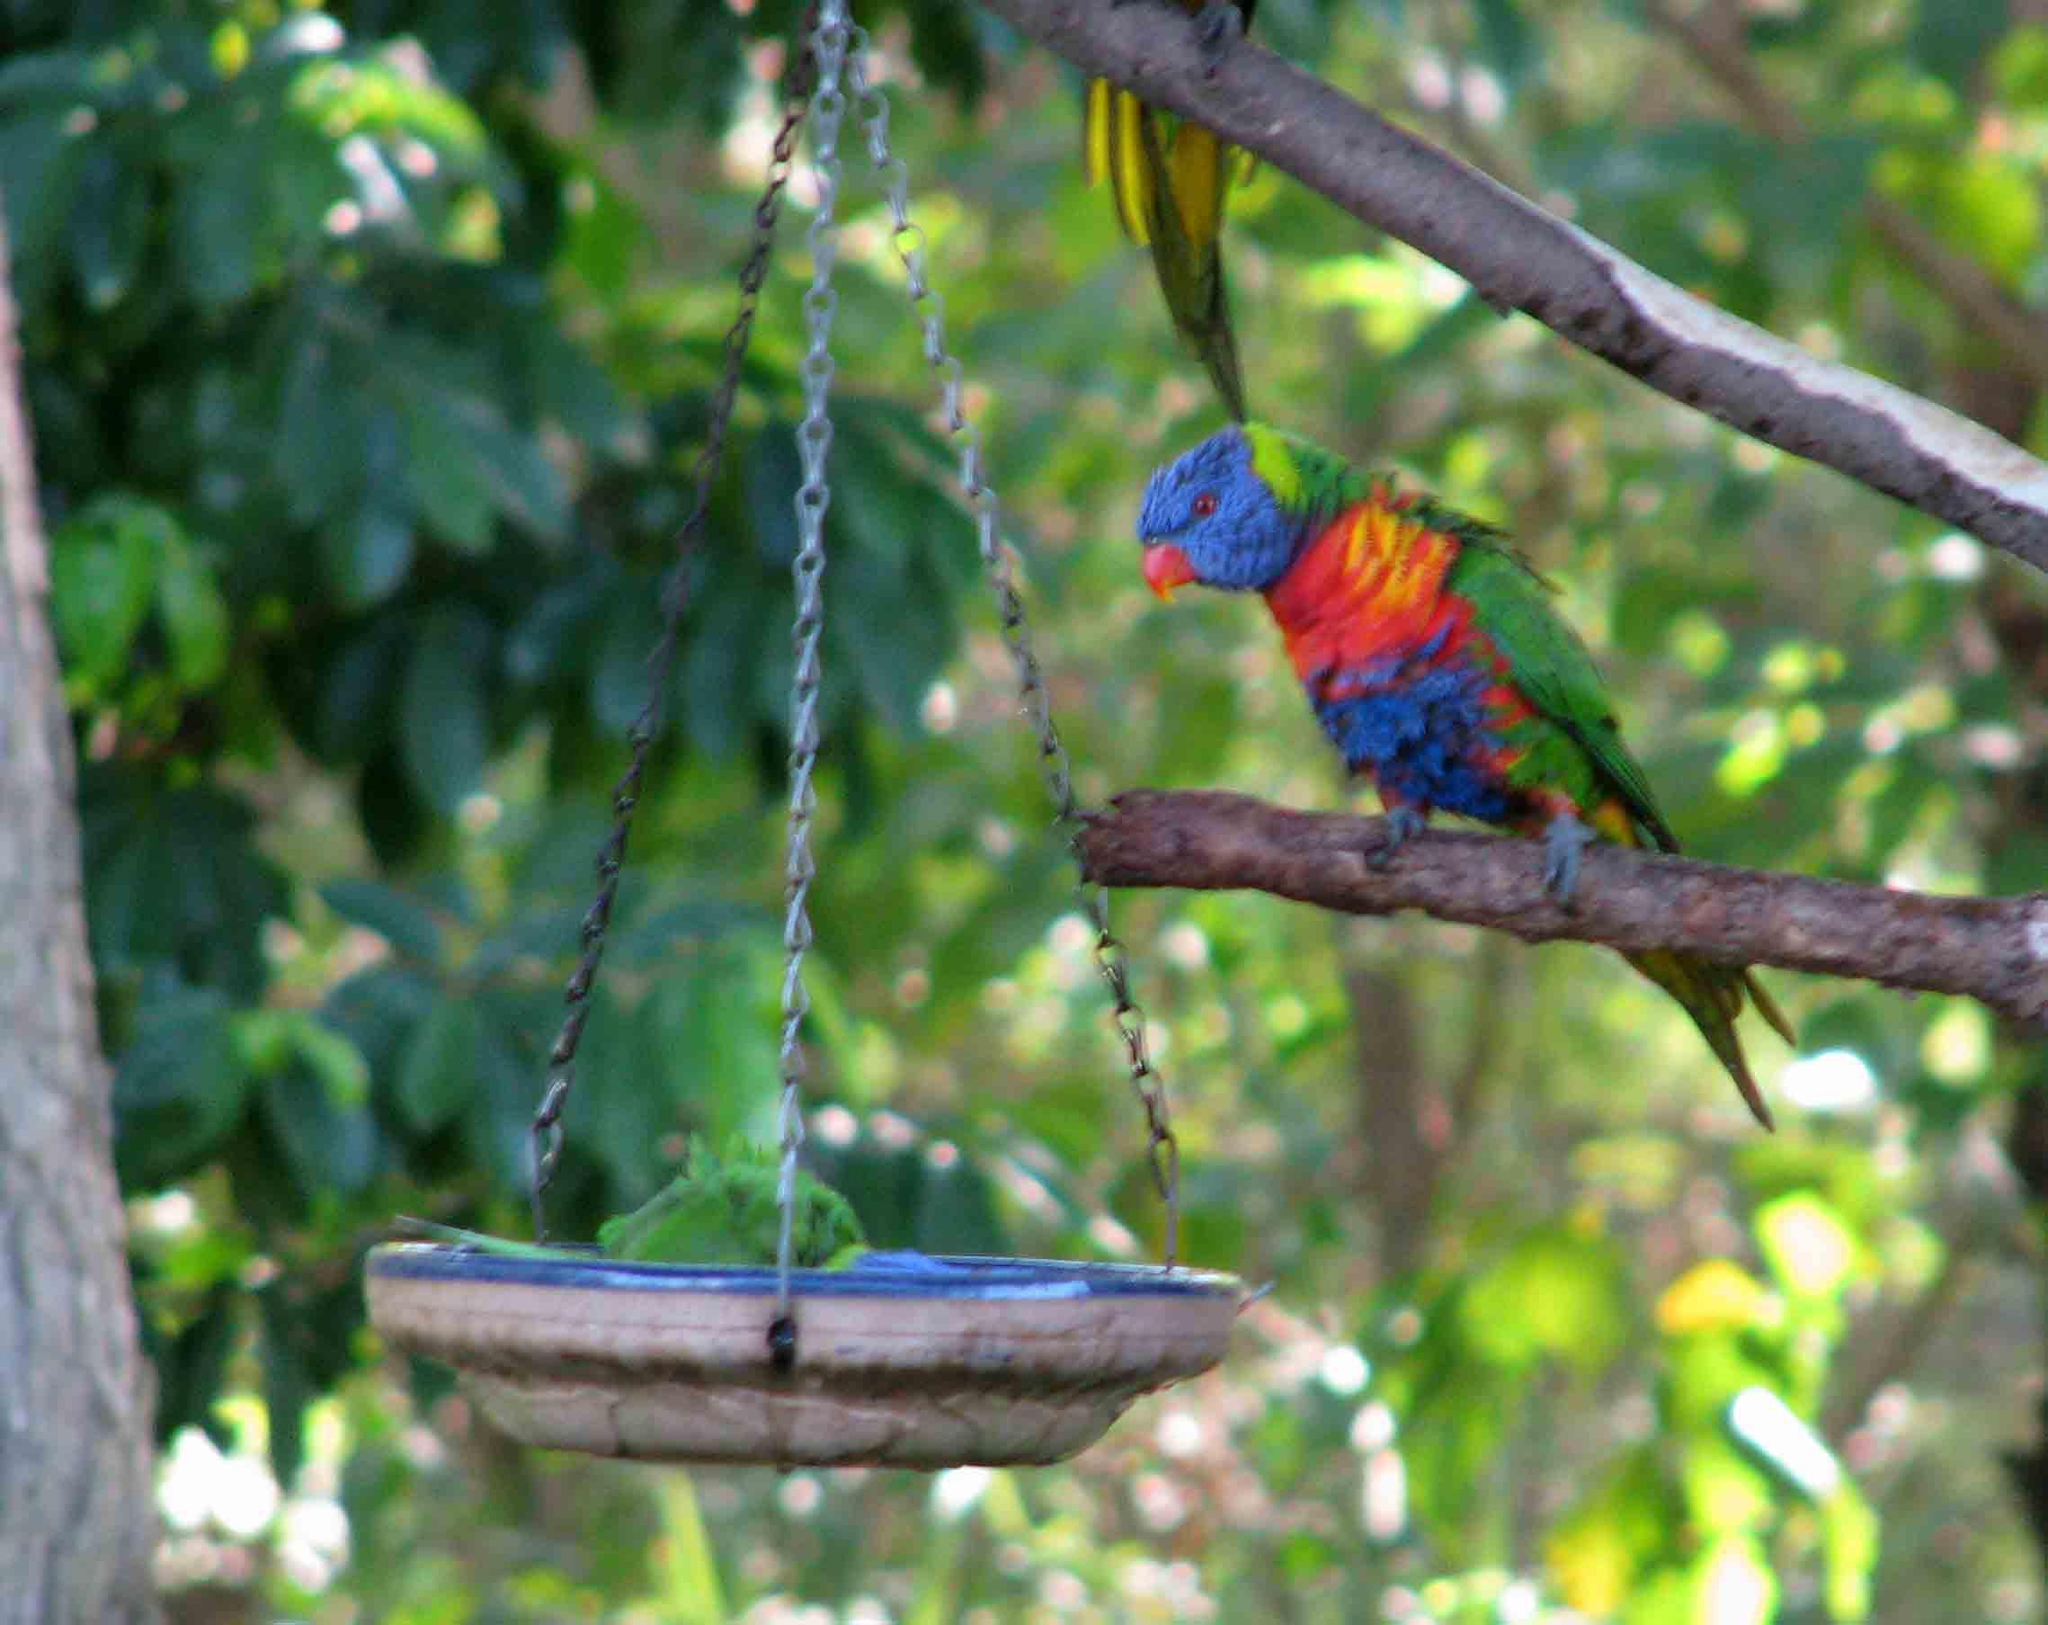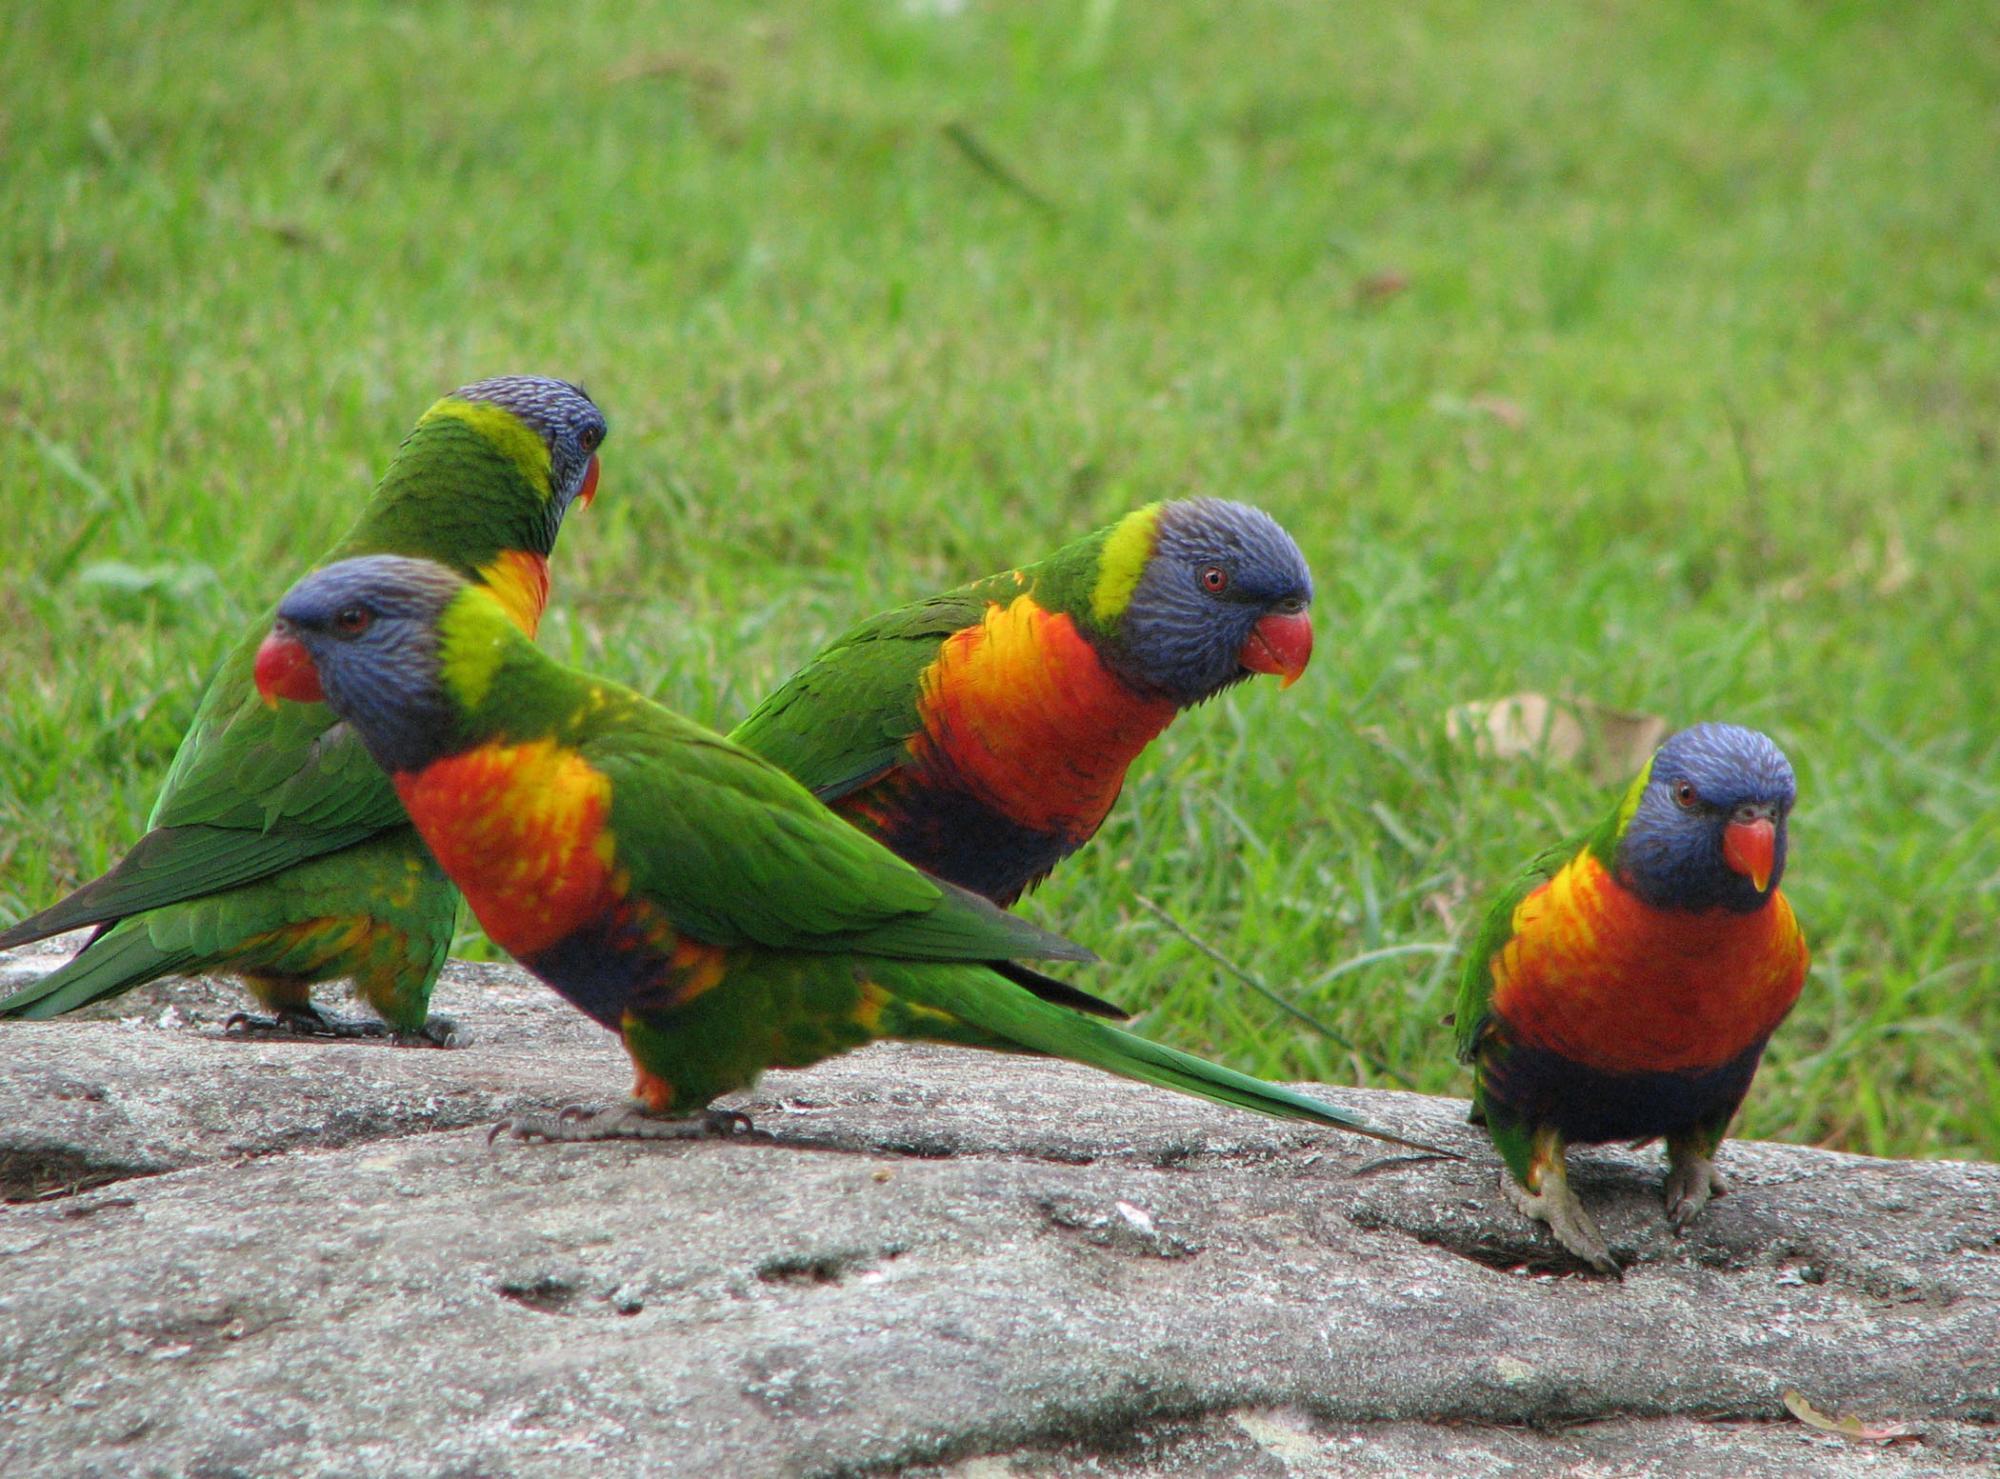The first image is the image on the left, the second image is the image on the right. Analyze the images presented: Is the assertion "Part of a human is pictured with a single bird in one of the images." valid? Answer yes or no. No. The first image is the image on the left, the second image is the image on the right. Evaluate the accuracy of this statement regarding the images: "One bird is upside down.". Is it true? Answer yes or no. No. 